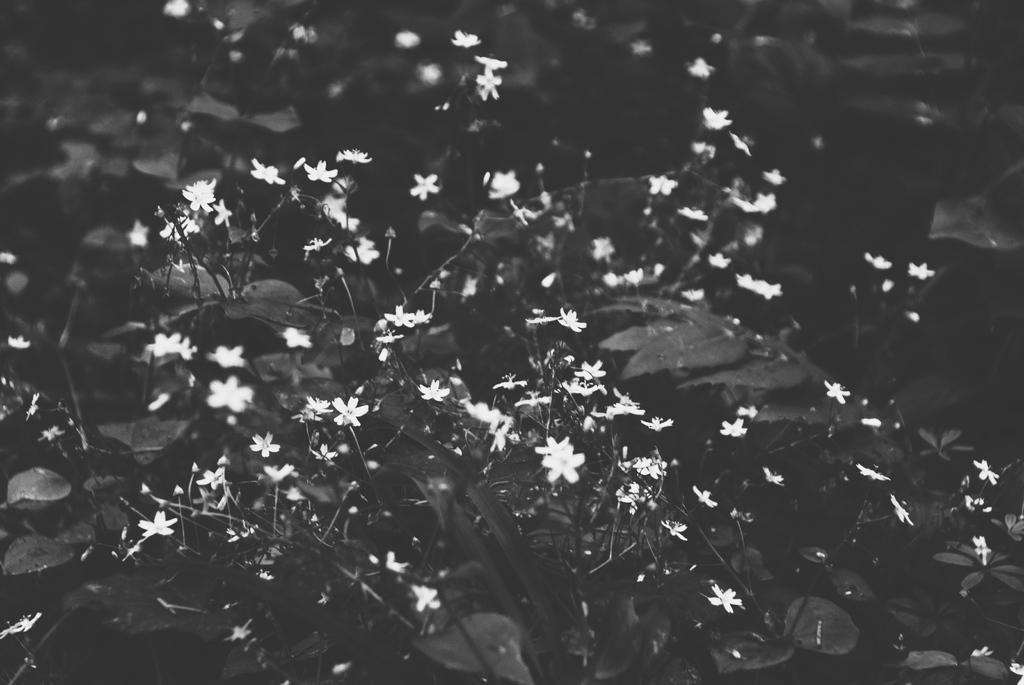How would you summarize this image in a sentence or two? This is a black and white image. In this image I can see plants along with the flowers. 